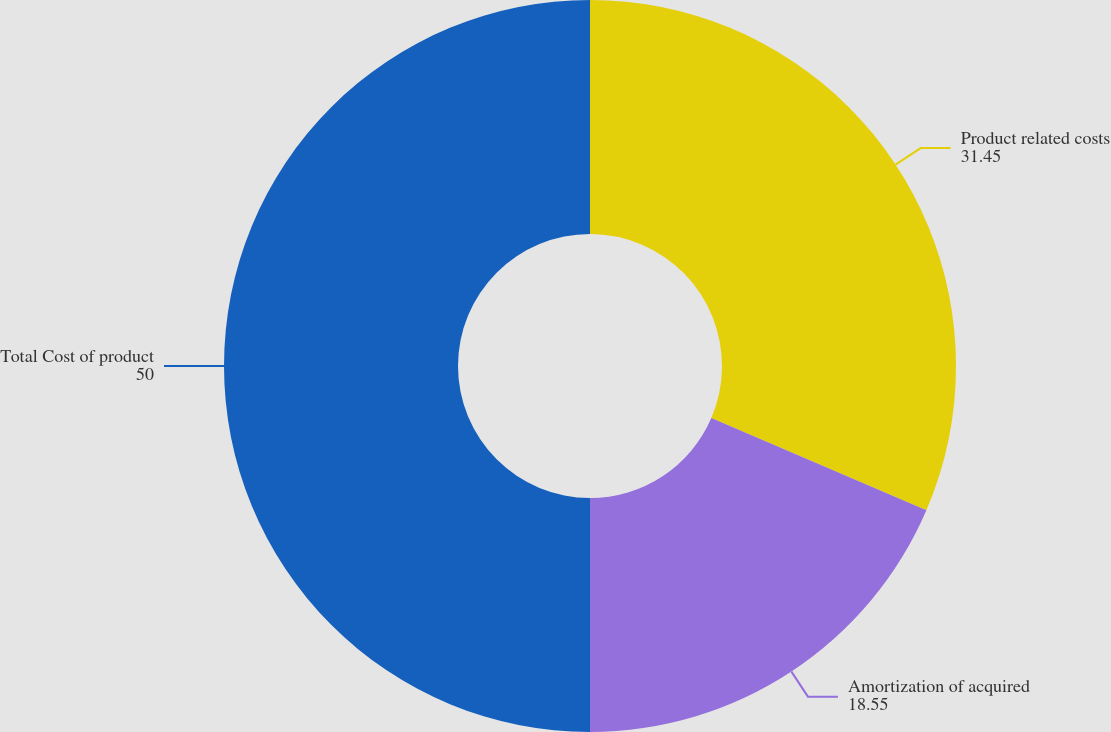Convert chart to OTSL. <chart><loc_0><loc_0><loc_500><loc_500><pie_chart><fcel>Product related costs<fcel>Amortization of acquired<fcel>Total Cost of product<nl><fcel>31.45%<fcel>18.55%<fcel>50.0%<nl></chart> 